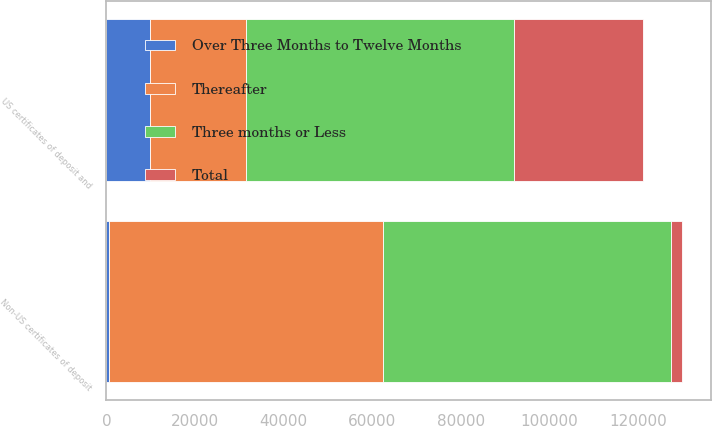Convert chart. <chart><loc_0><loc_0><loc_500><loc_500><stacked_bar_chart><ecel><fcel>US certificates of deposit and<fcel>Non-US certificates of deposit<nl><fcel>Thereafter<fcel>21486<fcel>61717<nl><fcel>Total<fcel>29097<fcel>2559<nl><fcel>Over Three Months to Twelve Months<fcel>9954<fcel>660<nl><fcel>Three months or Less<fcel>60537<fcel>64936<nl></chart> 